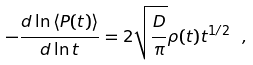Convert formula to latex. <formula><loc_0><loc_0><loc_500><loc_500>- \frac { d \ln \left < P ( t ) \right > } { d \ln t } = 2 \sqrt { \frac { D } { \pi } } \rho ( t ) t ^ { 1 / 2 } \ ,</formula> 